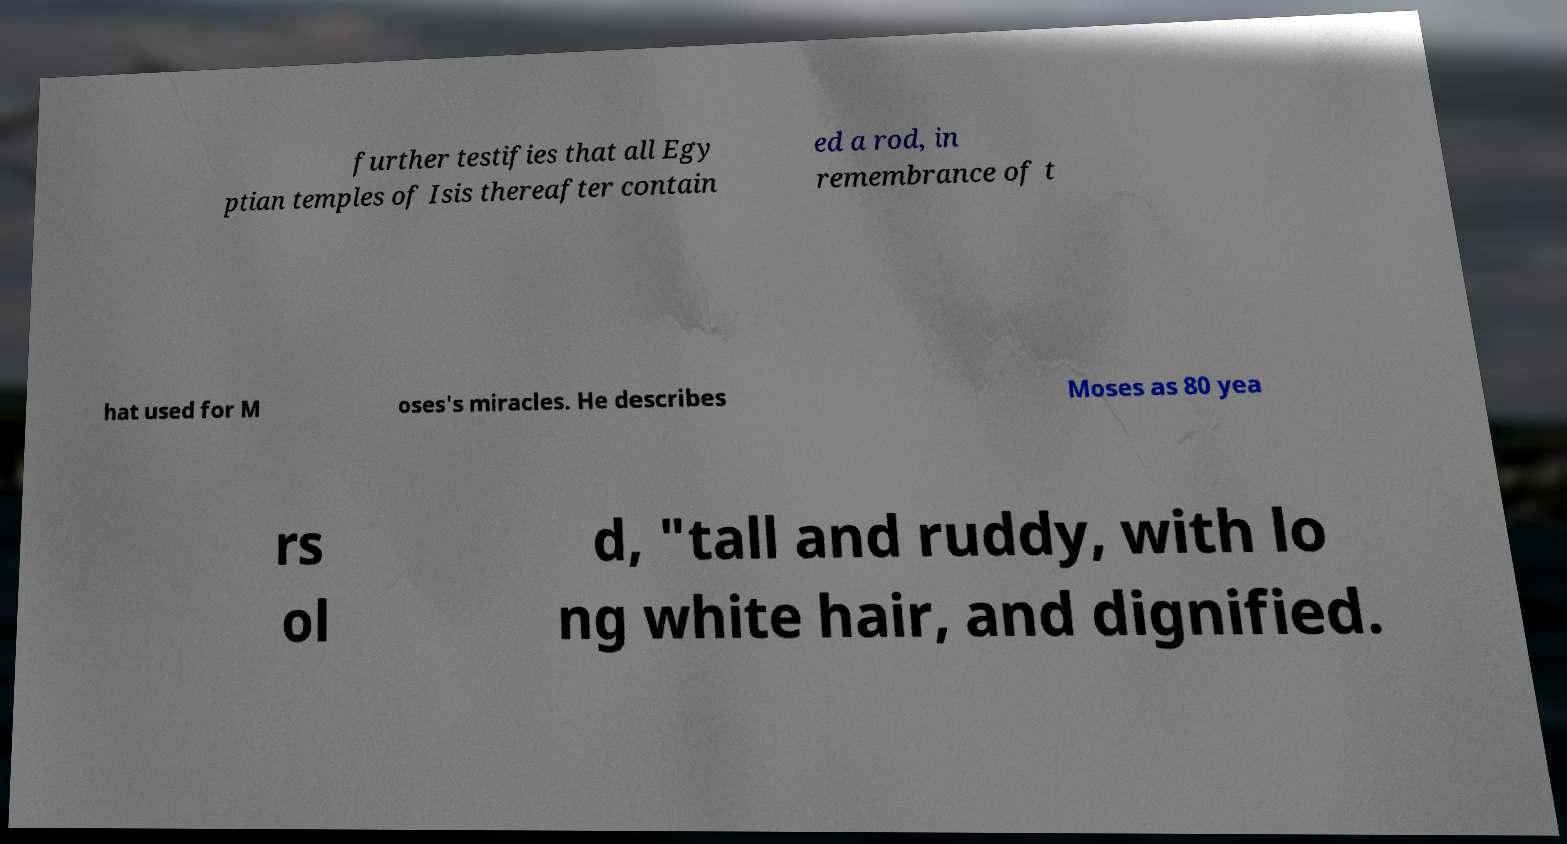What messages or text are displayed in this image? I need them in a readable, typed format. further testifies that all Egy ptian temples of Isis thereafter contain ed a rod, in remembrance of t hat used for M oses's miracles. He describes Moses as 80 yea rs ol d, "tall and ruddy, with lo ng white hair, and dignified. 